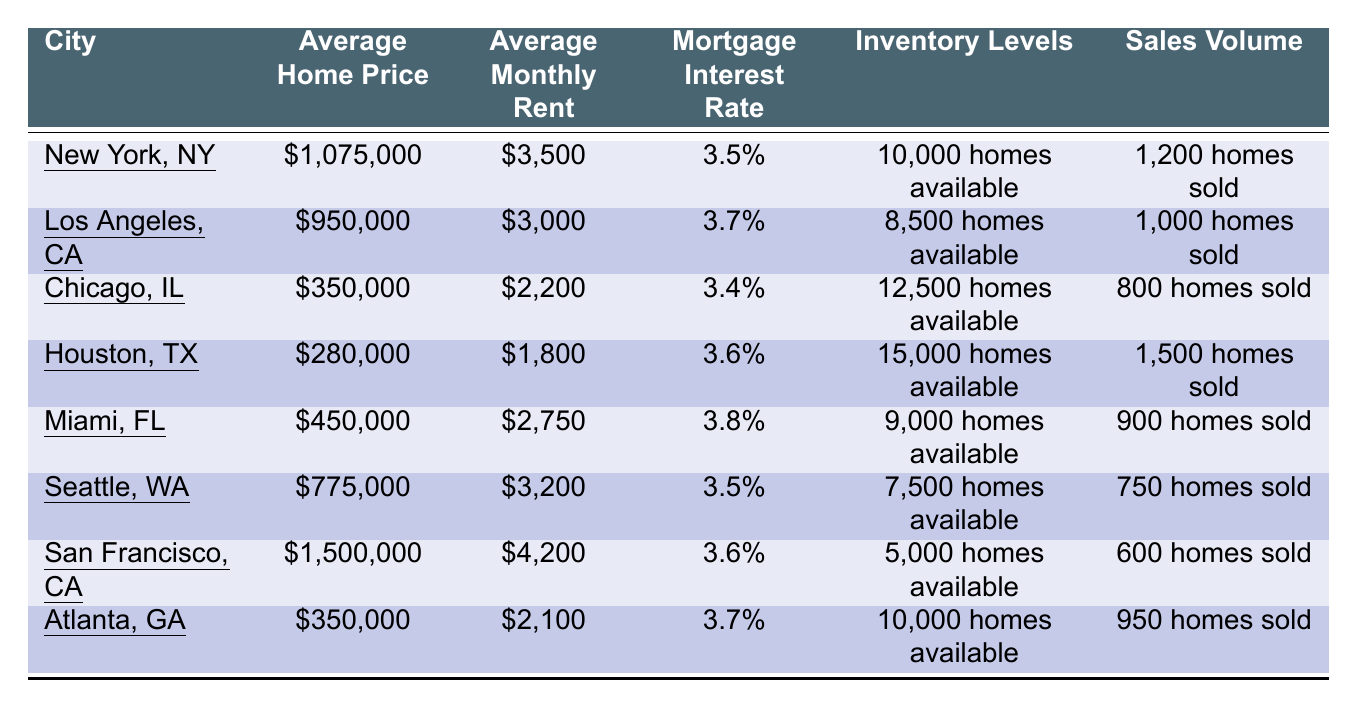What is the average home price in Houston, TX? The average home price listed in the table under Houston, TX is $280,000.
Answer: $280,000 Which city has the highest sales volume of homes sold? By reviewing the sales volumes, Houston, TX has the highest number of homes sold at 1,500.
Answer: Houston, TX What is the average mortgage interest rate across all cities? The mortgage interest rates are 3.5%, 3.7%, 3.4%, 3.6%, 3.8%, 3.5%, 3.6%, and 3.7%, totaling to 28.4%. Dividing by 8 (the number of cities) gives an average interest rate of 3.55%.
Answer: 3.55% Is the average monthly rent higher in New York, NY than in Los Angeles, CA? The average monthly rent in New York, NY is $3,500, which is higher than in Los Angeles, CA where it is $3,000.
Answer: Yes How many cities have an average home price below $500,000? The cities with average home prices below $500,000 are Chicago, IL ($350,000), Houston, TX ($280,000), and Atlanta, GA ($350,000), totaling to 3 cities.
Answer: 3 What is the difference in average monthly rent between Miami, FL and Seattle, WA? The average monthly rent in Miami, FL is $2,750, while in Seattle, WA it is $3,200. The difference is $3,200 - $2,750 = $450.
Answer: $450 Which city has the least inventory levels of homes available? By checking the inventory levels, San Francisco, CA has the least with only 5,000 homes available.
Answer: San Francisco, CA If you were to rent a home in Los Angeles, CA, how much would you be paying for rent over a year? The average monthly rent in Los Angeles, CA is $3,000. For a year, it would be $3,000 * 12 = $36,000.
Answer: $36,000 In which city is the mortgage interest rate the lowest? The lowest mortgage interest rate is in Chicago, IL at 3.4%.
Answer: Chicago, IL What is the total average home price for all cities combined? Adding the average home prices: $1,075,000 + $950,000 + $350,000 + $280,000 + $450,000 + $775,000 + $1,500,000 + $350,000 = $5,630,000. Dividing by 8 gives an average of $703,750.
Answer: $703,750 